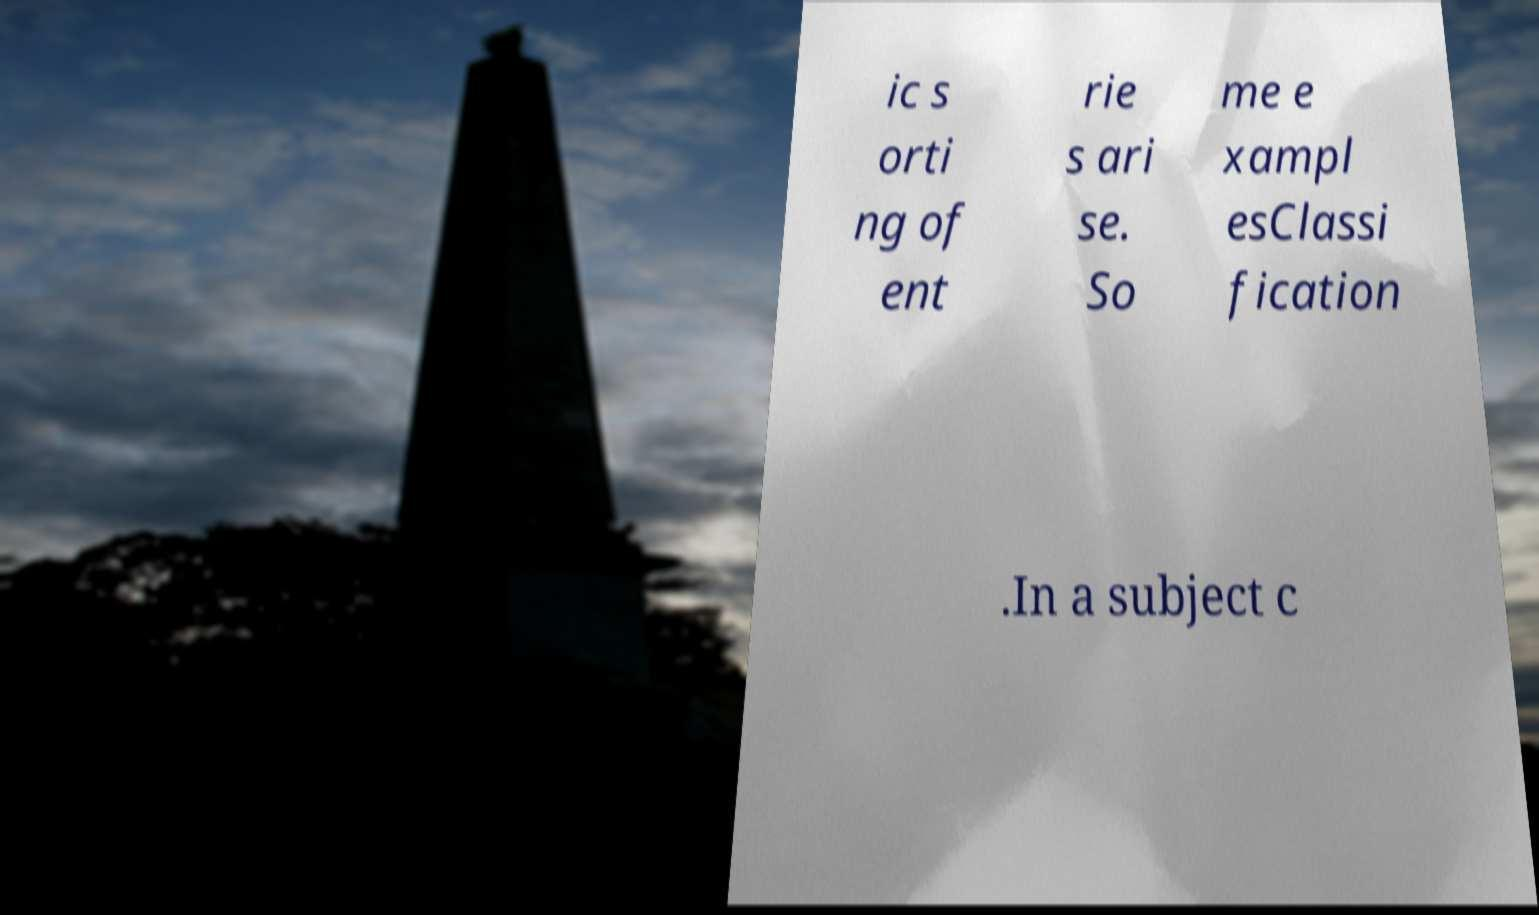Could you assist in decoding the text presented in this image and type it out clearly? ic s orti ng of ent rie s ari se. So me e xampl esClassi fication .In a subject c 